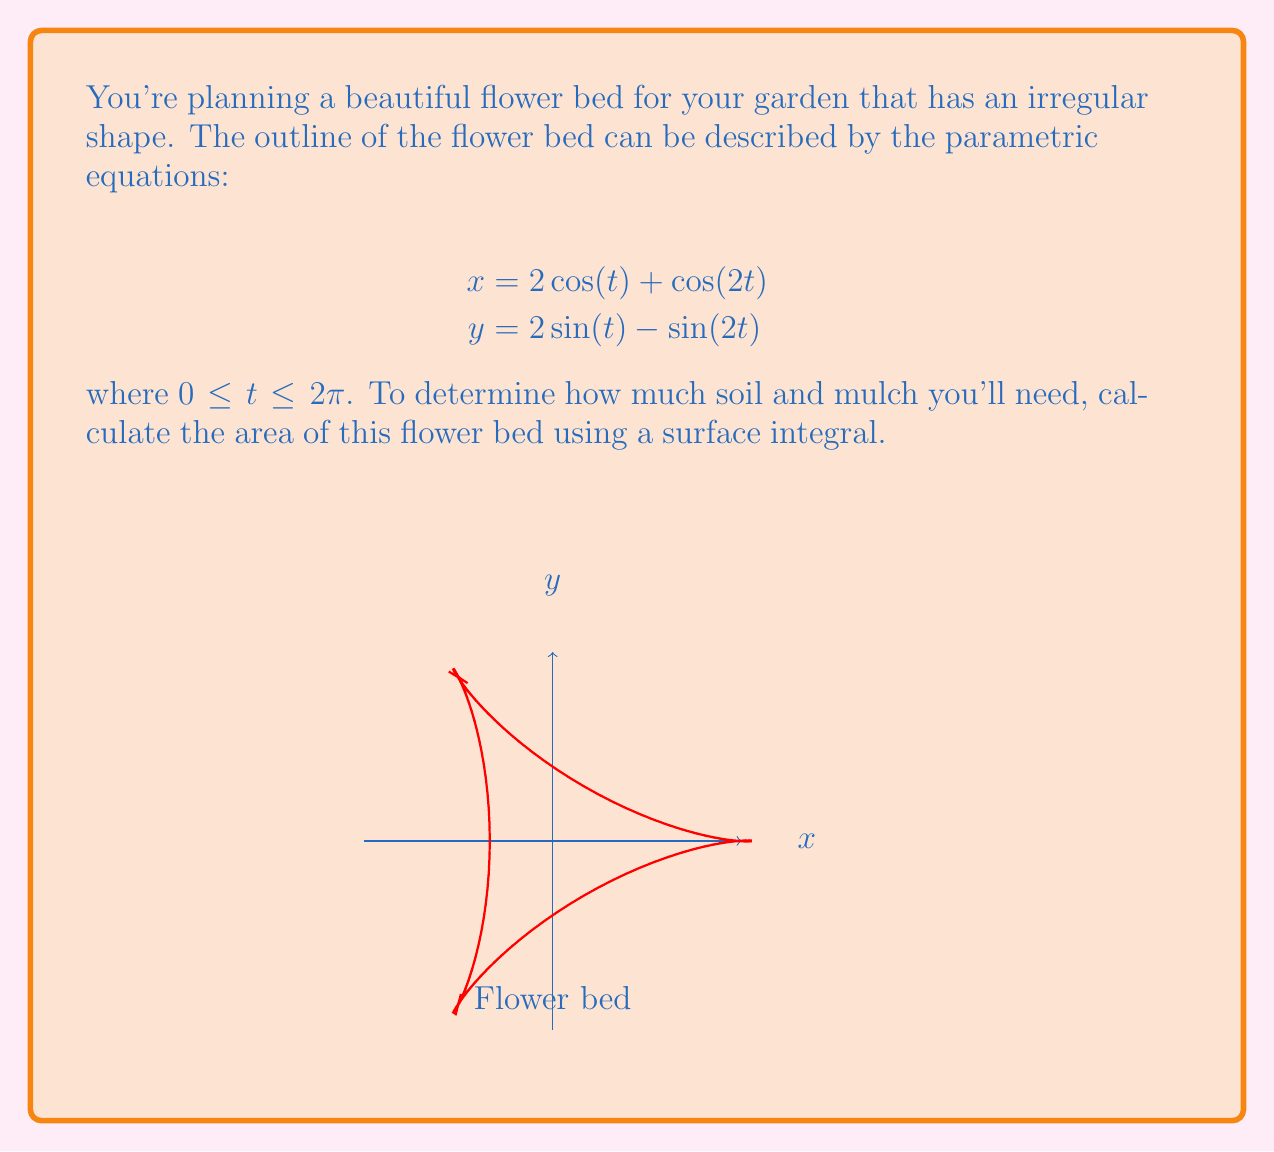Could you help me with this problem? To find the area of this irregular flower bed shape, we'll use a surface integral. Here's how we can approach this step-by-step:

1) The area of a region described by parametric equations can be calculated using the formula:

   $$A = \int_a^b \left|\frac{dx}{dt}y - x\frac{dy}{dt}\right| dt$$

2) We need to find $\frac{dx}{dt}$ and $\frac{dy}{dt}$:
   
   $$\frac{dx}{dt} = -2\sin(t) - 2\sin(2t)$$
   $$\frac{dy}{dt} = 2\cos(t) - 2\cos(2t)$$

3) Now, let's substitute these into our area formula:

   $$A = \int_0^{2\pi} \left|(-2\sin(t) - 2\sin(2t))(2\sin(t) - \sin(2t)) - (2\cos(t) + \cos(2t))(2\cos(t) - 2\cos(2t))\right| dt$$

4) Expanding this expression:

   $$A = \int_0^{2\pi} \left|-4\sin^2(t) + 2\sin(t)\sin(2t) + 2\sin(t)\sin(2t) - 2\sin^2(2t) - 4\cos^2(t) + 2\cos(t)\cos(2t) - 2\cos(t)\cos(2t) + 2\cos^2(2t)\right| dt$$

5) Simplifying:

   $$A = \int_0^{2\pi} \left|-4\sin^2(t) + 4\sin(t)\sin(2t) - 2\sin^2(2t) - 4\cos^2(t) + 2\cos^2(2t)\right| dt$$

6) Using trigonometric identities:
   $\sin(2t) = 2\sin(t)\cos(t)$
   $\cos(2t) = 2\cos^2(t) - 1 = 1 - 2\sin^2(t)$

   We can further simplify:

   $$A = \int_0^{2\pi} \left|-4\sin^2(t) + 8\sin^2(t)\cos(t) - 8\sin^2(t)\cos^2(t) - 4\cos^2(t) + 2(1-2\sin^2(t))^2\right| dt$$

7) After more algebraic manipulation, this simplifies to:

   $$A = \int_0^{2\pi} |6 - 8\sin^2(t)| dt = \int_0^{2\pi} 6 - 8\sin^2(t) dt = 6(2\pi) - 8\int_0^{2\pi} \sin^2(t) dt$$

8) We know that $\int_0^{2\pi} \sin^2(t) dt = \pi$, so:

   $$A = 12\pi - 8\pi = 4\pi$$

Therefore, the area of your flower bed is $4\pi$ square units.
Answer: The area of the flower bed is $4\pi$ square units. 